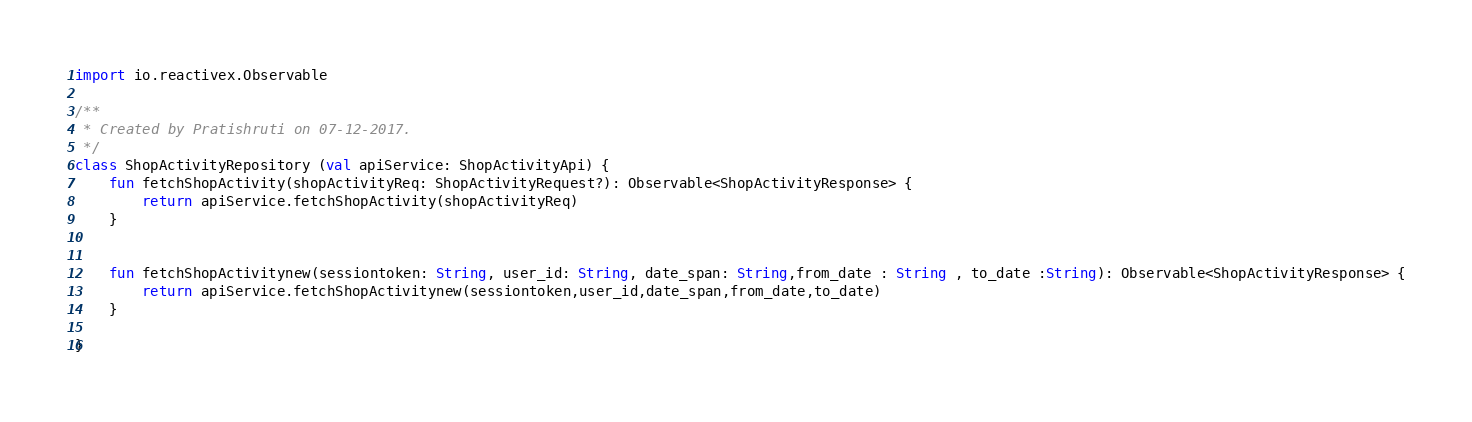<code> <loc_0><loc_0><loc_500><loc_500><_Kotlin_>import io.reactivex.Observable

/**
 * Created by Pratishruti on 07-12-2017.
 */
class ShopActivityRepository (val apiService: ShopActivityApi) {
    fun fetchShopActivity(shopActivityReq: ShopActivityRequest?): Observable<ShopActivityResponse> {
        return apiService.fetchShopActivity(shopActivityReq)
    }


    fun fetchShopActivitynew(sessiontoken: String, user_id: String, date_span: String,from_date : String , to_date :String): Observable<ShopActivityResponse> {
        return apiService.fetchShopActivitynew(sessiontoken,user_id,date_span,from_date,to_date)
    }

}</code> 